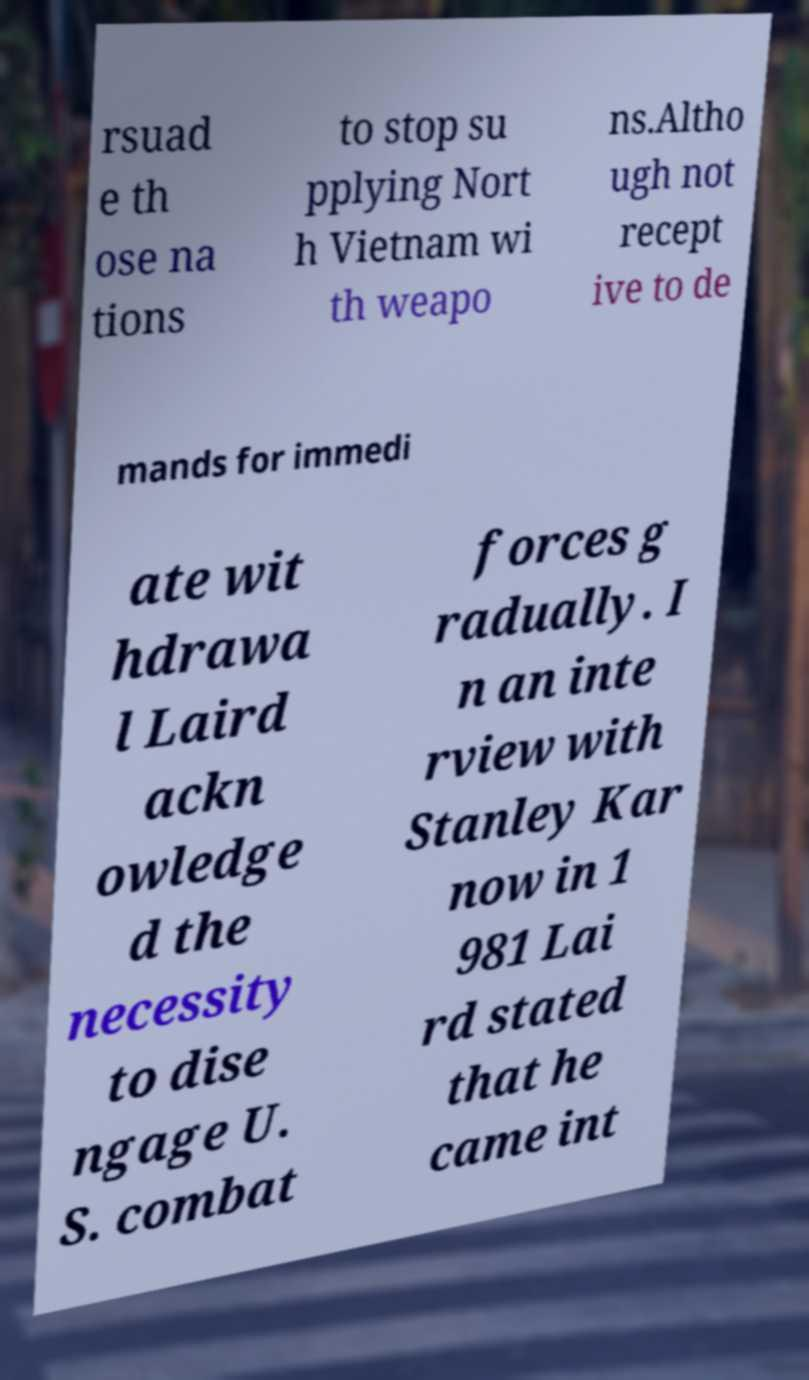Can you read and provide the text displayed in the image?This photo seems to have some interesting text. Can you extract and type it out for me? rsuad e th ose na tions to stop su pplying Nort h Vietnam wi th weapo ns.Altho ugh not recept ive to de mands for immedi ate wit hdrawa l Laird ackn owledge d the necessity to dise ngage U. S. combat forces g radually. I n an inte rview with Stanley Kar now in 1 981 Lai rd stated that he came int 